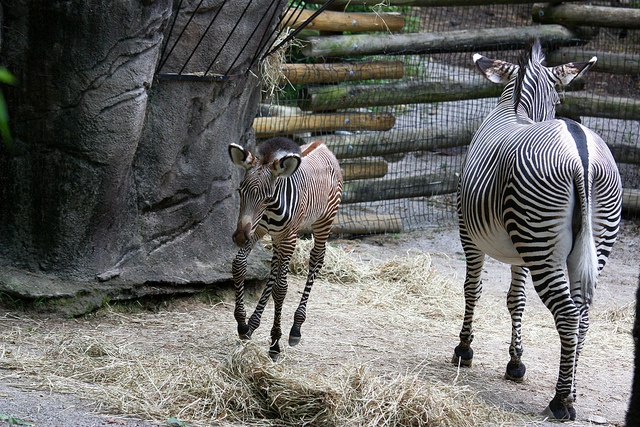Describe the objects in this image and their specific colors. I can see zebra in black, gray, lightgray, and darkgray tones and zebra in black, gray, darkgray, and lightgray tones in this image. 